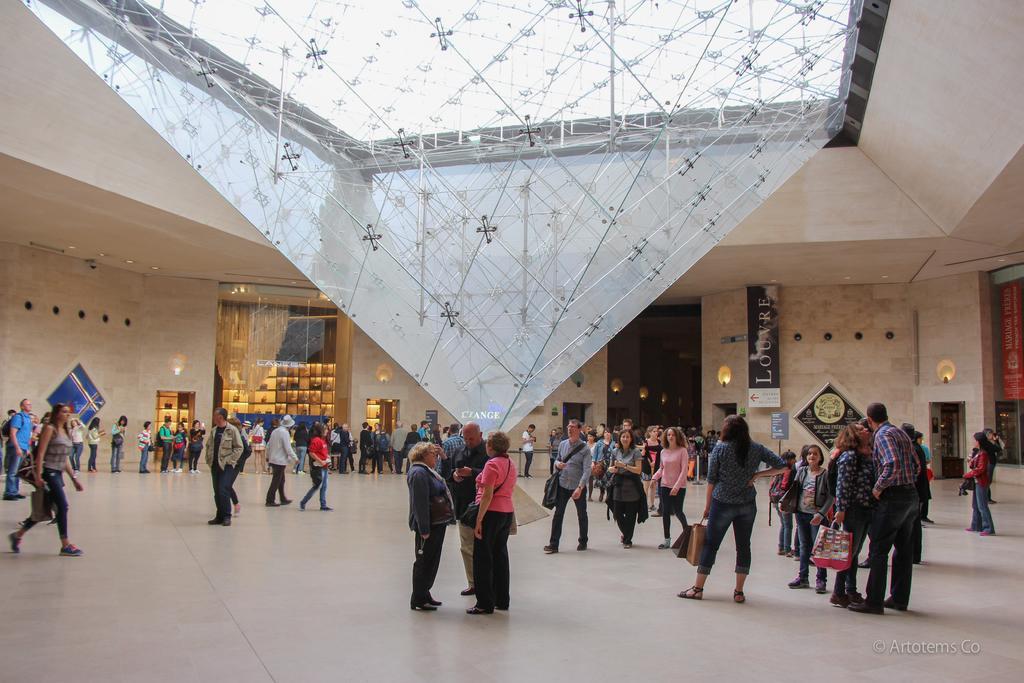How would you summarize this image in a sentence or two? In this image I can see inside view of a building and I can also see number of people are standing on the floor. I can also see most of people are holding bags. In the background I can see few boards and few lights on the walls. I can also see something is written on these boards. 